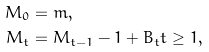<formula> <loc_0><loc_0><loc_500><loc_500>M _ { 0 } & = m , \\ M _ { t } & = M _ { t - 1 } - 1 + B _ { t } t \geq 1 ,</formula> 